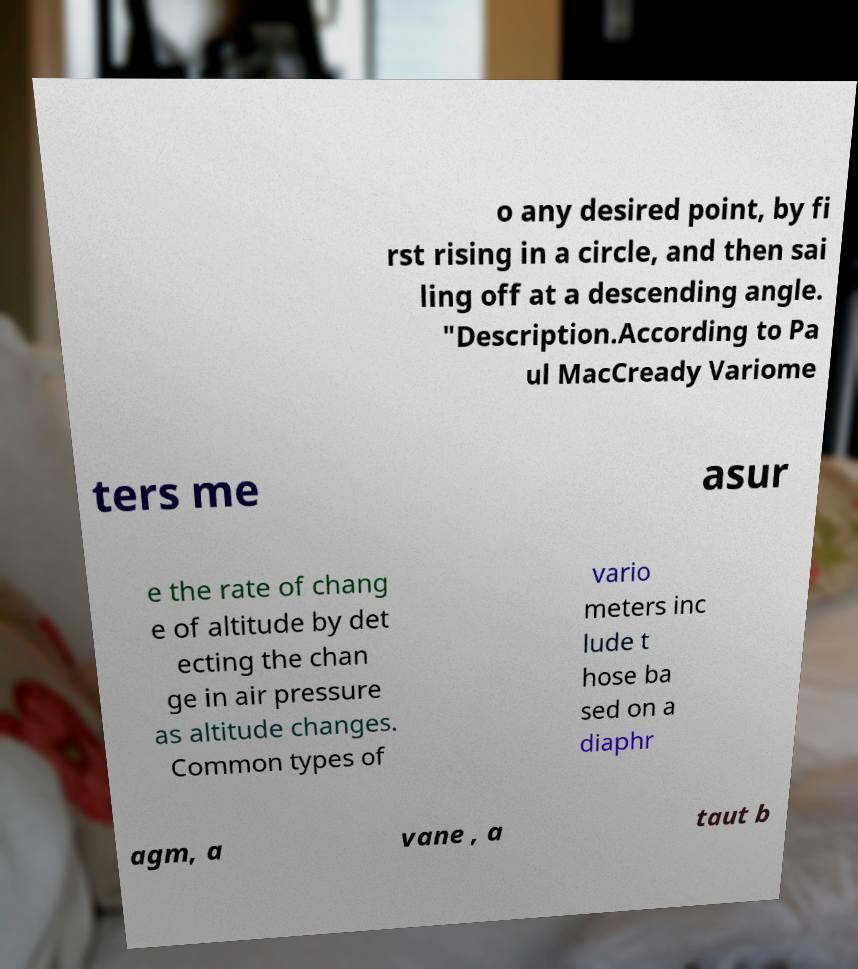What messages or text are displayed in this image? I need them in a readable, typed format. o any desired point, by fi rst rising in a circle, and then sai ling off at a descending angle. "Description.According to Pa ul MacCready Variome ters me asur e the rate of chang e of altitude by det ecting the chan ge in air pressure as altitude changes. Common types of vario meters inc lude t hose ba sed on a diaphr agm, a vane , a taut b 